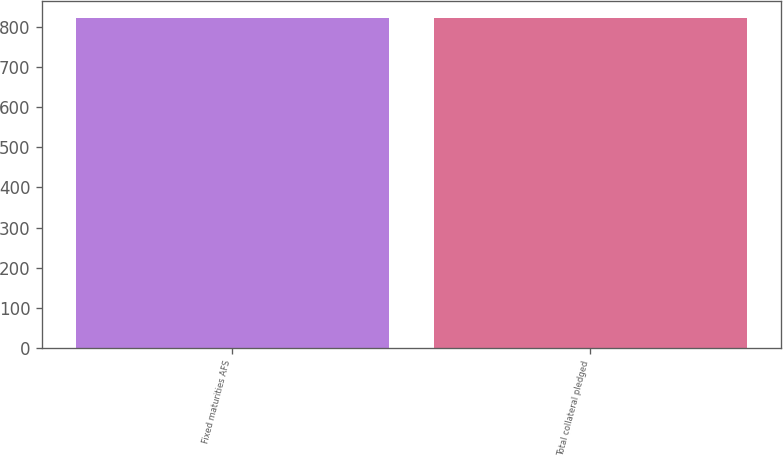Convert chart to OTSL. <chart><loc_0><loc_0><loc_500><loc_500><bar_chart><fcel>Fixed maturities AFS<fcel>Total collateral pledged<nl><fcel>823<fcel>823.1<nl></chart> 